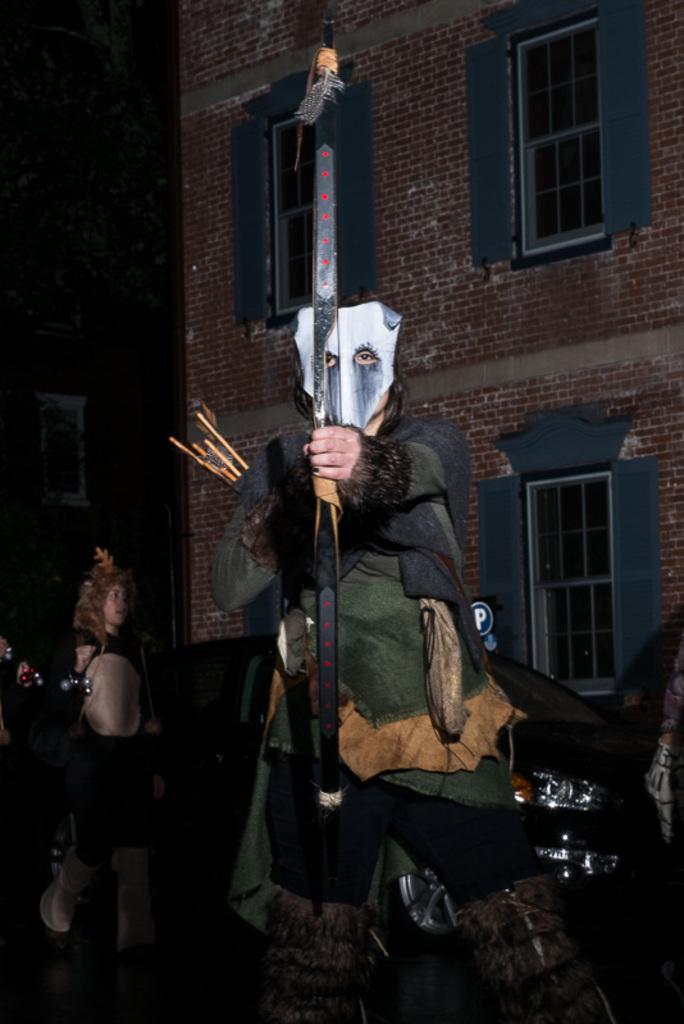Please provide a concise description of this image. Here in this picture we can see a person present on the ground with a costume on him and he is holding a bow in his hands and carrying arrows with him and behind him also we can see people walking on the road with costumes on them and we can see cars present and we see buildings with windows on it present over there. 